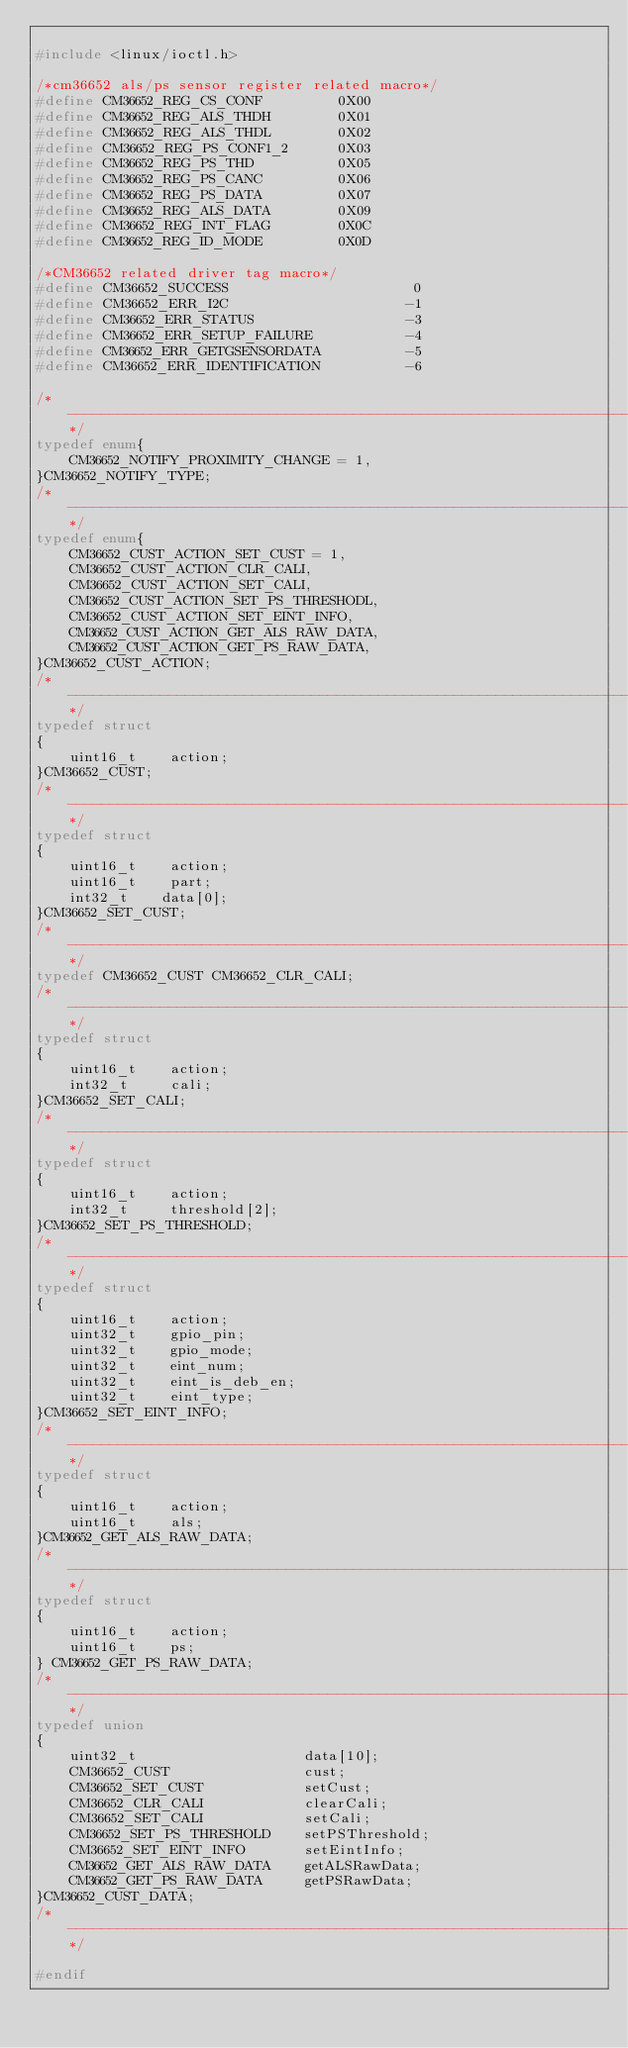<code> <loc_0><loc_0><loc_500><loc_500><_C_>
#include <linux/ioctl.h>

/*cm36652 als/ps sensor register related macro*/
#define CM36652_REG_CS_CONF 		0X00
#define CM36652_REG_ALS_THDH 		0X01
#define CM36652_REG_ALS_THDL 		0X02
#define CM36652_REG_PS_CONF1_2		0X03
#define CM36652_REG_PS_THD			0X05
#define CM36652_REG_PS_CANC			0X06
#define CM36652_REG_PS_DATA			0X07
#define CM36652_REG_ALS_DATA		0X09
#define CM36652_REG_INT_FLAG		0X0C
#define CM36652_REG_ID_MODE			0X0D

/*CM36652 related driver tag macro*/
#define CM36652_SUCCESS				 		 0
#define CM36652_ERR_I2C						-1
#define CM36652_ERR_STATUS					-3
#define CM36652_ERR_SETUP_FAILURE			-4
#define CM36652_ERR_GETGSENSORDATA			-5
#define CM36652_ERR_IDENTIFICATION			-6

/*----------------------------------------------------------------------------*/
typedef enum{
    CM36652_NOTIFY_PROXIMITY_CHANGE = 1,
}CM36652_NOTIFY_TYPE;
/*----------------------------------------------------------------------------*/
typedef enum{
    CM36652_CUST_ACTION_SET_CUST = 1,
    CM36652_CUST_ACTION_CLR_CALI,
    CM36652_CUST_ACTION_SET_CALI,
    CM36652_CUST_ACTION_SET_PS_THRESHODL,
    CM36652_CUST_ACTION_SET_EINT_INFO,
    CM36652_CUST_ACTION_GET_ALS_RAW_DATA,
    CM36652_CUST_ACTION_GET_PS_RAW_DATA,
}CM36652_CUST_ACTION;
/*----------------------------------------------------------------------------*/
typedef struct
{
    uint16_t    action;
}CM36652_CUST;
/*----------------------------------------------------------------------------*/
typedef struct
{
    uint16_t    action;
    uint16_t    part;
    int32_t    data[0];
}CM36652_SET_CUST;
/*----------------------------------------------------------------------------*/
typedef CM36652_CUST CM36652_CLR_CALI;
/*----------------------------------------------------------------------------*/
typedef struct
{
    uint16_t    action;
    int32_t     cali;
}CM36652_SET_CALI;
/*----------------------------------------------------------------------------*/
typedef struct
{
    uint16_t    action;
    int32_t     threshold[2];
}CM36652_SET_PS_THRESHOLD;
/*----------------------------------------------------------------------------*/
typedef struct
{
    uint16_t    action;
    uint32_t    gpio_pin;
    uint32_t    gpio_mode;
    uint32_t    eint_num;
    uint32_t    eint_is_deb_en;
    uint32_t    eint_type;
}CM36652_SET_EINT_INFO;
/*----------------------------------------------------------------------------*/
typedef struct
{
    uint16_t    action;
    uint16_t    als;
}CM36652_GET_ALS_RAW_DATA;
/*----------------------------------------------------------------------------*/
typedef struct
{
    uint16_t    action;
    uint16_t    ps;
} CM36652_GET_PS_RAW_DATA;
/*----------------------------------------------------------------------------*/
typedef union
{
    uint32_t                    data[10];
    CM36652_CUST                cust;
    CM36652_SET_CUST            setCust;
    CM36652_CLR_CALI            clearCali;
    CM36652_SET_CALI            setCali;
    CM36652_SET_PS_THRESHOLD    setPSThreshold;
    CM36652_SET_EINT_INFO       setEintInfo;
    CM36652_GET_ALS_RAW_DATA    getALSRawData;
    CM36652_GET_PS_RAW_DATA     getPSRawData;
}CM36652_CUST_DATA;
/*----------------------------------------------------------------------------*/

#endif

</code> 